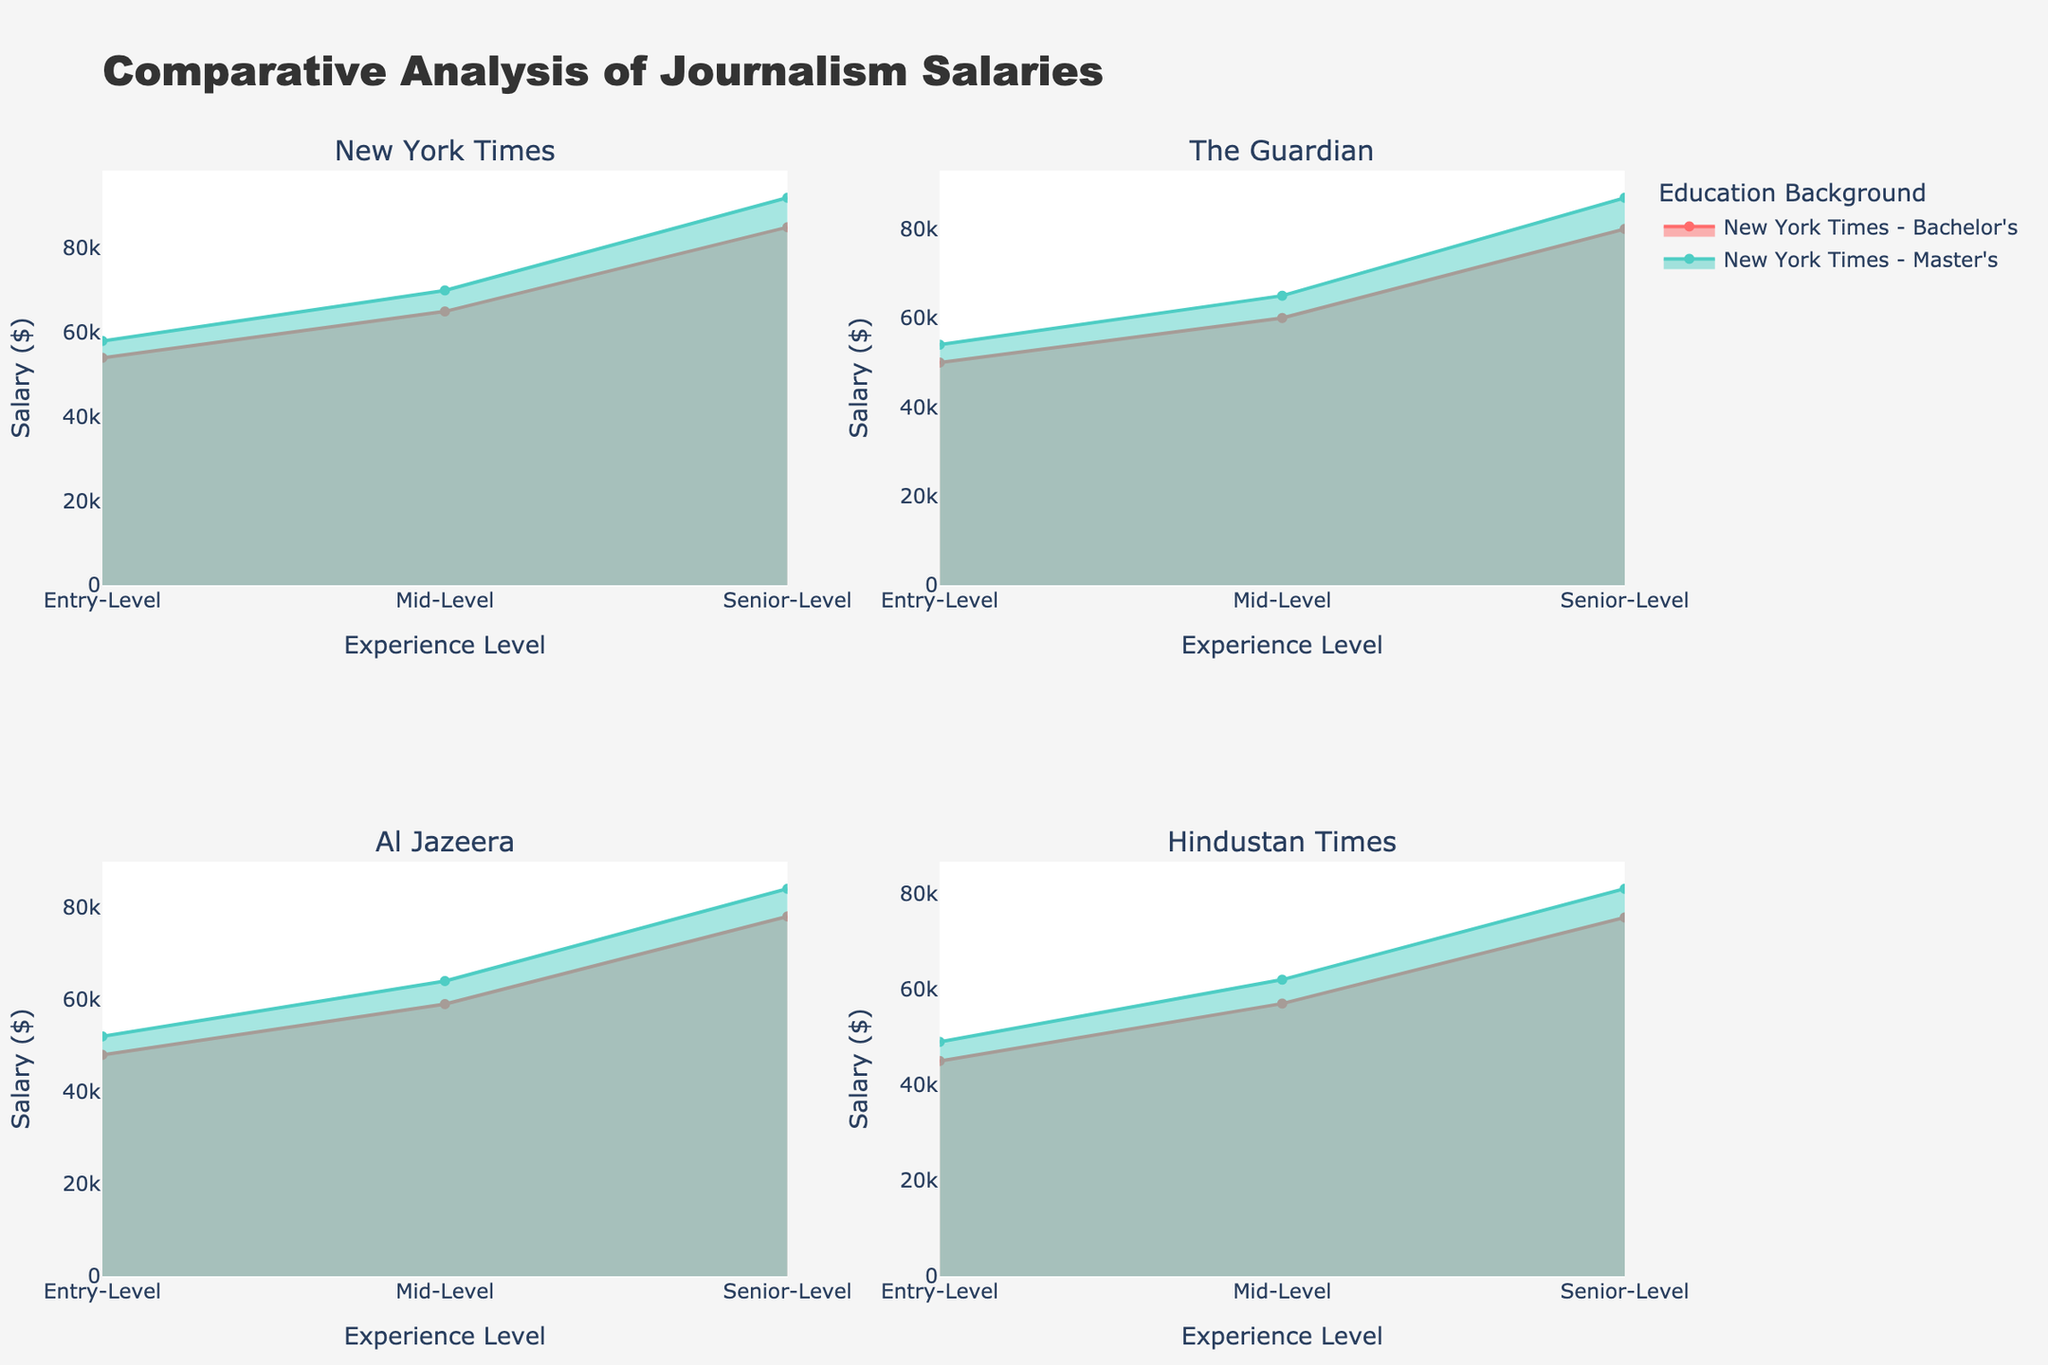What is the highest salary for a senior-level journalist with a Master's degree? To find this, locate the subplot for each company and observe the highest point on the 'Senior-Level, Master's' line. The maximum values are: New York Times ($92,000), The Guardian ($87,000), Al Jazeera ($84,000), and Hindustan Times ($81,000). Therefore, the highest among these is $92,000 at the New York Times.
Answer: $92,000 Which company offers the lowest salary for entry-level journalists with a Bachelor's degree? Check the subplot for each company and find the lowest salary for 'Entry-Level, Bachelor's' across all companies: New York Times ($54,000), The Guardian ($50,000), Al Jazeera ($48,000), and Hindustan Times ($45,000). The lowest is with Hindustan Times at $45,000.
Answer: Hindustan Times Compare the salary difference between entry-level and mid-level journalists with a Master's degree at Al Jazeera. Locate the Al Jazeera subplot, find the salary for 'Entry-Level, Master's' ($52,000) and 'Mid-Level, Master's' ($64,000). Subtract entry-level from mid-level: $64,000 - $52,000 = $12,000.
Answer: $12,000 Which company shows the largest salary increase from mid-level to senior-level for journalists with a Master's degree? Locate mid-level and senior-level Master's salary for each subplot. Calculate the difference: 
- New York Times: $92,000 - $70,000 = $22,000
- The Guardian: $87,000 - $65,000 = $22,000
- Al Jazeera: $84,000 - $64,000 = $20,000
- Hindustan Times: $81,000 - $62,000 = $19,000
The largest increase is $22,000, seen at both New York Times and The Guardian.
Answer: New York Times and The Guardian What is the trend of salary differences at the New York Times for journalists with a Bachelor's vs. Master's degree across experience levels? Evaluate salary differences at each experience level for New York Times:
- Entry-Level: $58,000 - $54,000 = $4,000
- Mid-Level: $70,000 - $65,000 = $5,000
- Senior-Level: $92,000 - $85,000 = $7,000
The difference increases from $4,000 to $7,000 as experience level rises.
Answer: Increases from $4,000 to $7,000 What is the average salary for a senior-level journalist across all companies? Add the senior-level salaries from all companies and divide by the number of companies:
New York Times ($85,000, $92,000), The Guardian ($80,000, $87,000), Al Jazeera ($78,000, $84,000), Hindustan Times ($75,000, $81,000).
Average = (85,000 + 92,000 + 80,000 + 87,000 + 78,000 + 84,000 + 75,000 + 81,000) / 8 = $82,750.
Answer: $82,750 How is the salary progression for journalists with a Bachelor's degree different between New York Times and Hindustan Times? Observe the Bachelor's progression for both companies:
- New York Times: $54,000 (Entry) -> $65,000 (Mid) -> $85,000 (Senior)
- Hindustan Times: $45,000 (Entry) -> $57,000 (Mid) -> $75,000 (Senior)
The salary gap between each level is greater at New York Times, showing a steeper progression.
Answer: Steeper progression at New York Times Which education background shows a more significant salary increase from entry-level to senior-level at The Guardian? Calculate the difference for Bachelor’s and Master’s between these levels:
- Bachelor's: $80,000 (Senior) - $50,000 (Entry) = $30,000
- Master's: $87,000 (Senior) - $54,000 (Entry) = $33,000
Master's degree has a higher increase ($33,000).
Answer: Master’s Degree 